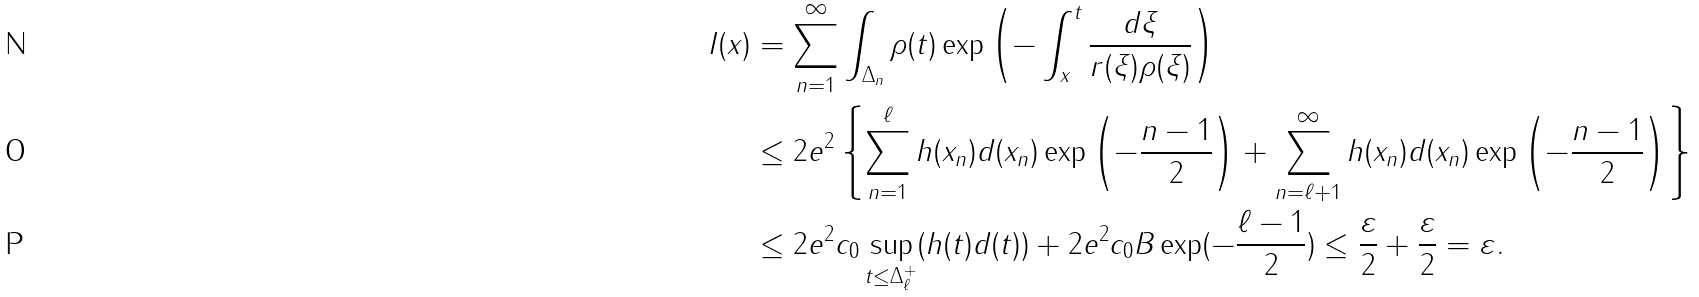<formula> <loc_0><loc_0><loc_500><loc_500>I ( x ) & = \sum _ { n = 1 } ^ { \infty } \int _ { \Delta _ { n } } \rho ( t ) \exp \left ( - \int _ { x } ^ { t } \frac { d \xi } { r ( \xi ) \rho ( \xi ) } \right ) \\ & \leq 2 e ^ { 2 } \left \{ \sum _ { n = 1 } ^ { \ell } h ( x _ { n } ) d ( x _ { n } ) \exp \left ( - \frac { n - 1 } { 2 } \right ) + \sum _ { n = \ell + 1 } ^ { \infty } h ( x _ { n } ) d ( x _ { n } ) \exp \left ( - \frac { n - 1 } { 2 } \right ) \right \} \\ & \leq 2 e ^ { 2 } c _ { 0 } \sup _ { t \leq \Delta _ { \ell } ^ { + } } ( h ( t ) d ( t ) ) + 2 e ^ { 2 } c _ { 0 } B \exp ( - \frac { \ell - 1 } { 2 } ) \leq \frac { \varepsilon } { 2 } + \frac { \varepsilon } { 2 } = \varepsilon .</formula> 